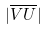Convert formula to latex. <formula><loc_0><loc_0><loc_500><loc_500>| \overline { V U } |</formula> 